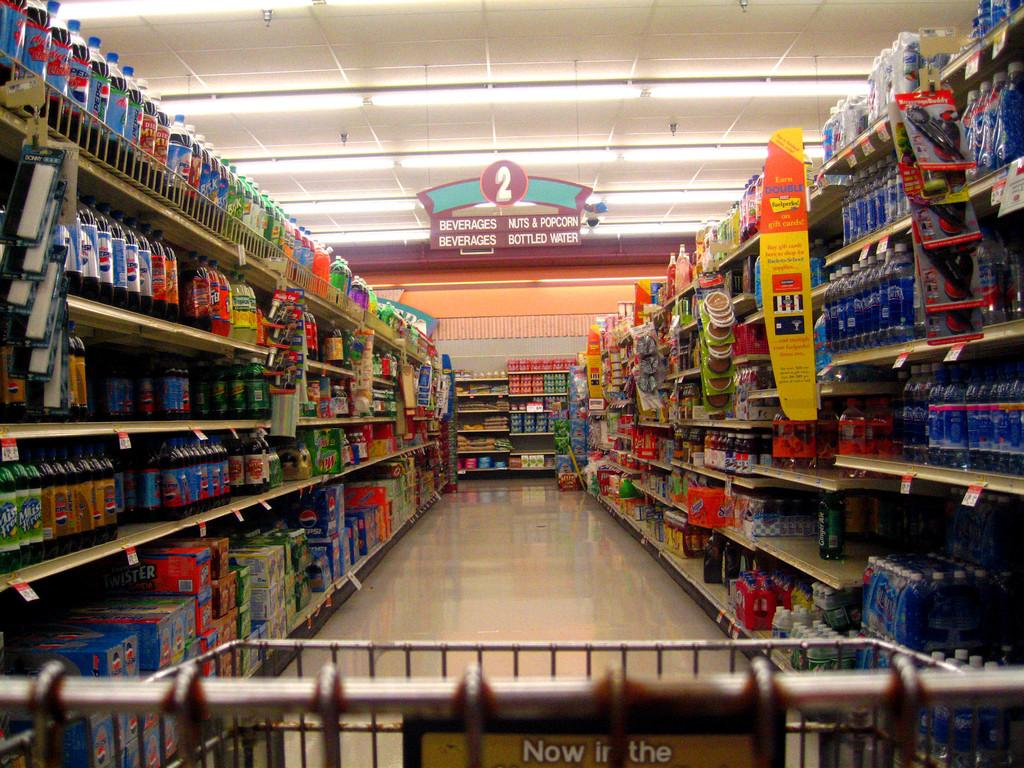Provide a one-sentence caption for the provided image. The aisle in a store where Nuts & Popcorn can be found. 